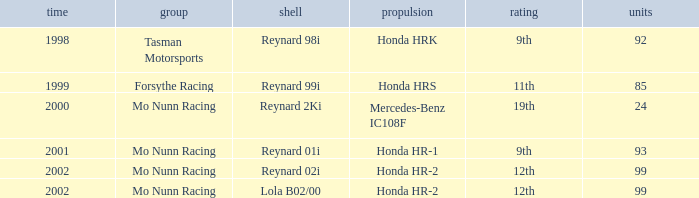What is the total number of points of the honda hr-1 engine? 1.0. 